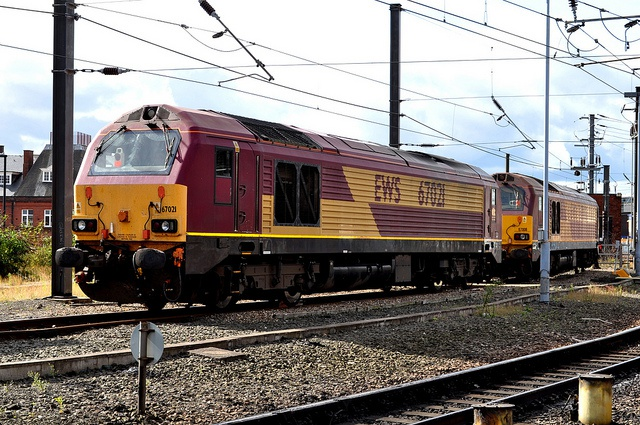Describe the objects in this image and their specific colors. I can see a train in white, black, maroon, and gray tones in this image. 